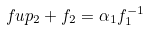Convert formula to latex. <formula><loc_0><loc_0><loc_500><loc_500>\ f u p _ { 2 } + f _ { 2 } = \alpha _ { 1 } f _ { 1 } ^ { - 1 }</formula> 